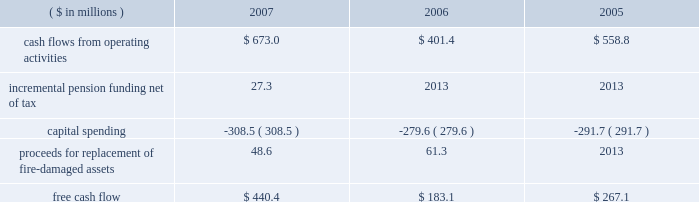Page 30 of 94 are included in capital spending amounts .
Another example is the company 2019s decision in 2007 to contribute an additional $ 44.5 million ( $ 27.3 million ) to its pension plans as part of its overall debt reduction plan .
Based on this , our consolidated free cash flow is summarized as follows: .
Based on information currently available , we estimate cash flows from operating activities for 2008 to be approximately $ 650 million , capital spending to be approximately $ 350 million and free cash flow to be in the $ 300 million range .
Capital spending of $ 259.9 million ( net of $ 48.6 million in insurance recoveries ) in 2007 was below depreciation and amortization expense of $ 281 million .
We continue to invest capital in our best performing operations , including projects to increase custom can capabilities , improve beverage can and end making productivity and add more beverage can capacity in europe , as well as expenditures in the aerospace and technologies segment .
Of the $ 350 million of planned capital spending for 2008 , approximately $ 180 million will be spent on top-line sales growth projects .
Debt facilities and refinancing interest-bearing debt at december 31 , 2007 , decreased $ 93.1 million to $ 2358.6 million from $ 2451.7 million at december 31 , 2006 .
The 2007 debt decrease from 2006 was primarily attributed to debt payments offset by higher foreign exchange rates .
At december 31 , 2007 , $ 705 million was available under the company 2019s multi-currency revolving credit facilities .
The company also had $ 345 million of short-term uncommitted credit facilities available at the end of the year , of which $ 49.7 million was outstanding .
On october 13 , 2005 , ball refinanced its senior secured credit facilities and during the third and fourth quarters of 2005 , ball redeemed its 7.75% ( 7.75 % ) senior notes due august 2006 primarily through the drawdown of funds under the new credit facilities .
The refinancing and redemption resulted in a pretax debt refinancing charge of $ 19.3 million ( $ 12.3 million after tax ) to reflect the call premium associated with the senior notes and the write off of unamortized debt issuance costs .
The company has a receivables sales agreement that provides for the ongoing , revolving sale of a designated pool of trade accounts receivable of ball 2019s north american packaging operations , up to $ 250 million .
The agreement qualifies as off-balance sheet financing under the provisions of statement of financial accounting standards ( sfas ) no .
140 , as amended by sfas no .
156 .
Net funds received from the sale of the accounts receivable totaled $ 170 million and $ 201.3 million at december 31 , 2007 and 2006 , respectively , and are reflected as a reduction of accounts receivable in the consolidated balance sheets .
The company was not in default of any loan agreement at december 31 , 2007 , and has met all payment obligations .
The u.s .
Note agreements , bank credit agreement and industrial development revenue bond agreements contain certain restrictions relating to dividends , investments , financial ratios , guarantees and the incurrence of additional indebtedness .
Additional details about the company 2019s receivables sales agreement and debt are available in notes 7 and 13 , respectively , accompanying the consolidated financial statements within item 8 of this report. .
What is the percentage change in cash flow from operating activities from 2006 to 2007? 
Computations: ((673.0 - 401.4) / 401.4)
Answer: 0.67663. Page 30 of 94 are included in capital spending amounts .
Another example is the company 2019s decision in 2007 to contribute an additional $ 44.5 million ( $ 27.3 million ) to its pension plans as part of its overall debt reduction plan .
Based on this , our consolidated free cash flow is summarized as follows: .
Based on information currently available , we estimate cash flows from operating activities for 2008 to be approximately $ 650 million , capital spending to be approximately $ 350 million and free cash flow to be in the $ 300 million range .
Capital spending of $ 259.9 million ( net of $ 48.6 million in insurance recoveries ) in 2007 was below depreciation and amortization expense of $ 281 million .
We continue to invest capital in our best performing operations , including projects to increase custom can capabilities , improve beverage can and end making productivity and add more beverage can capacity in europe , as well as expenditures in the aerospace and technologies segment .
Of the $ 350 million of planned capital spending for 2008 , approximately $ 180 million will be spent on top-line sales growth projects .
Debt facilities and refinancing interest-bearing debt at december 31 , 2007 , decreased $ 93.1 million to $ 2358.6 million from $ 2451.7 million at december 31 , 2006 .
The 2007 debt decrease from 2006 was primarily attributed to debt payments offset by higher foreign exchange rates .
At december 31 , 2007 , $ 705 million was available under the company 2019s multi-currency revolving credit facilities .
The company also had $ 345 million of short-term uncommitted credit facilities available at the end of the year , of which $ 49.7 million was outstanding .
On october 13 , 2005 , ball refinanced its senior secured credit facilities and during the third and fourth quarters of 2005 , ball redeemed its 7.75% ( 7.75 % ) senior notes due august 2006 primarily through the drawdown of funds under the new credit facilities .
The refinancing and redemption resulted in a pretax debt refinancing charge of $ 19.3 million ( $ 12.3 million after tax ) to reflect the call premium associated with the senior notes and the write off of unamortized debt issuance costs .
The company has a receivables sales agreement that provides for the ongoing , revolving sale of a designated pool of trade accounts receivable of ball 2019s north american packaging operations , up to $ 250 million .
The agreement qualifies as off-balance sheet financing under the provisions of statement of financial accounting standards ( sfas ) no .
140 , as amended by sfas no .
156 .
Net funds received from the sale of the accounts receivable totaled $ 170 million and $ 201.3 million at december 31 , 2007 and 2006 , respectively , and are reflected as a reduction of accounts receivable in the consolidated balance sheets .
The company was not in default of any loan agreement at december 31 , 2007 , and has met all payment obligations .
The u.s .
Note agreements , bank credit agreement and industrial development revenue bond agreements contain certain restrictions relating to dividends , investments , financial ratios , guarantees and the incurrence of additional indebtedness .
Additional details about the company 2019s receivables sales agreement and debt are available in notes 7 and 13 , respectively , accompanying the consolidated financial statements within item 8 of this report. .
How much of the 2008 planned capital spending will impact top line revenue? 
Computations: (180 / 350)
Answer: 0.51429. 